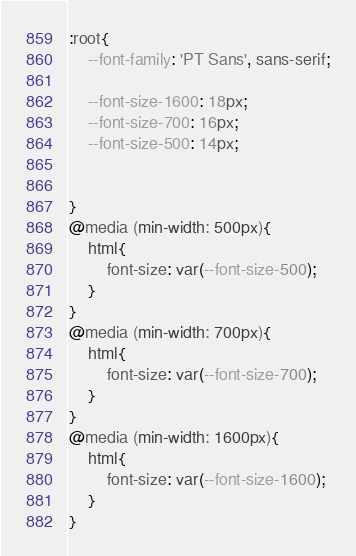<code> <loc_0><loc_0><loc_500><loc_500><_CSS_>:root{
    --font-family: 'PT Sans', sans-serif;
    
    --font-size-1600: 18px;
    --font-size-700: 16px;
    --font-size-500: 14px;

    
}
@media (min-width: 500px){
    html{
        font-size: var(--font-size-500);
    }
}
@media (min-width: 700px){
    html{
        font-size: var(--font-size-700);
    }
}
@media (min-width: 1600px){
    html{
        font-size: var(--font-size-1600);
    }
}</code> 